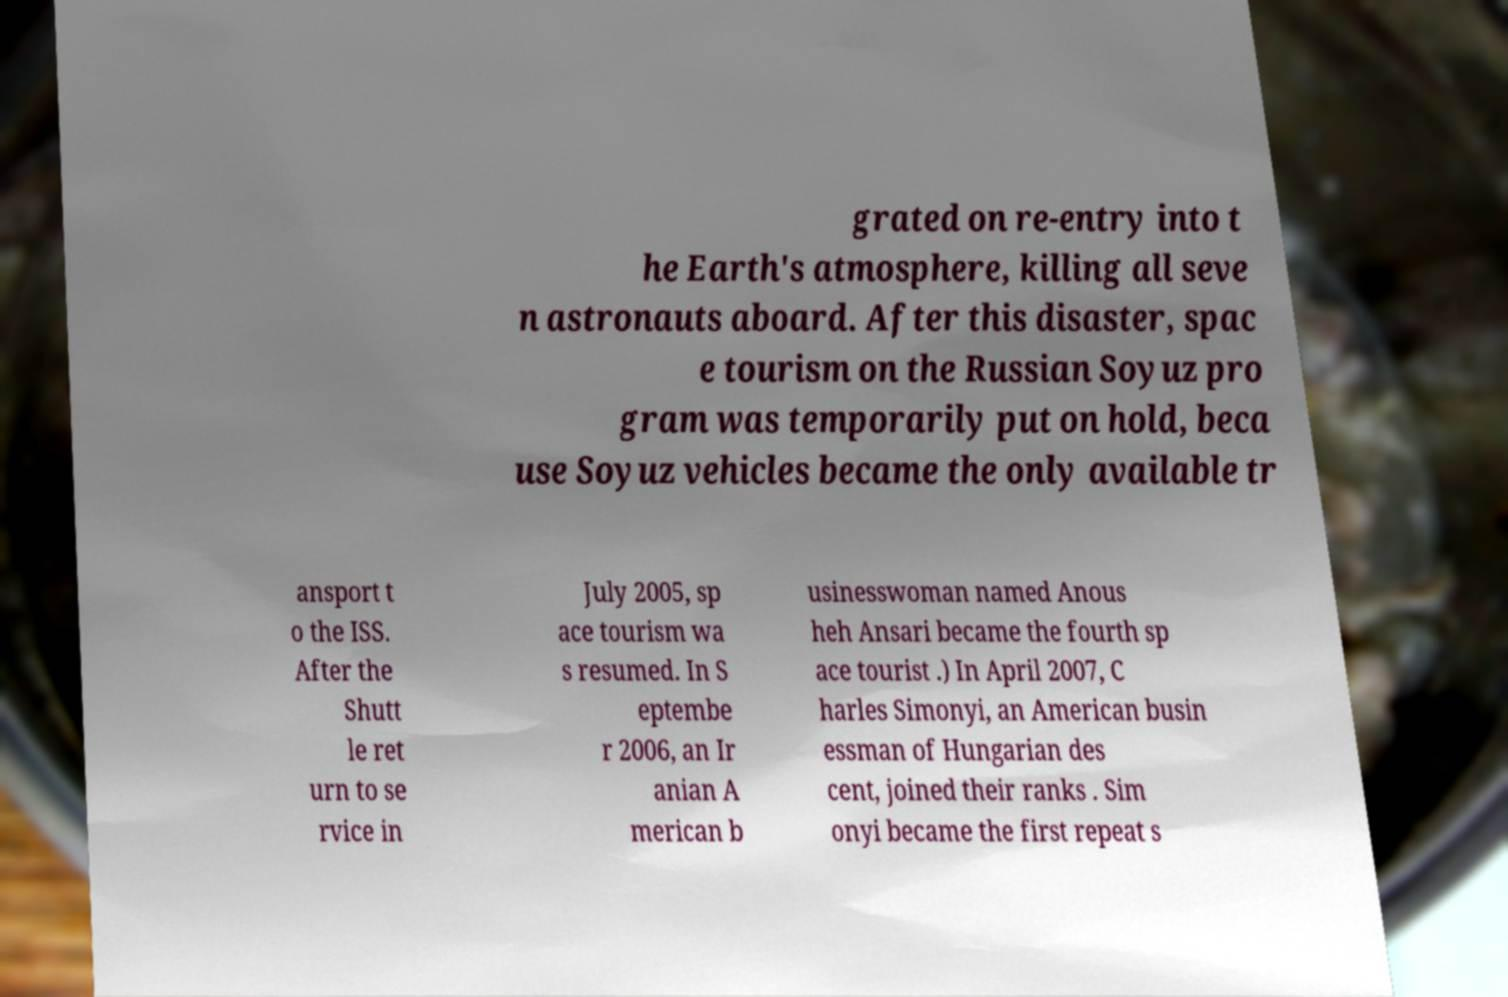For documentation purposes, I need the text within this image transcribed. Could you provide that? grated on re-entry into t he Earth's atmosphere, killing all seve n astronauts aboard. After this disaster, spac e tourism on the Russian Soyuz pro gram was temporarily put on hold, beca use Soyuz vehicles became the only available tr ansport t o the ISS. After the Shutt le ret urn to se rvice in July 2005, sp ace tourism wa s resumed. In S eptembe r 2006, an Ir anian A merican b usinesswoman named Anous heh Ansari became the fourth sp ace tourist .) In April 2007, C harles Simonyi, an American busin essman of Hungarian des cent, joined their ranks . Sim onyi became the first repeat s 